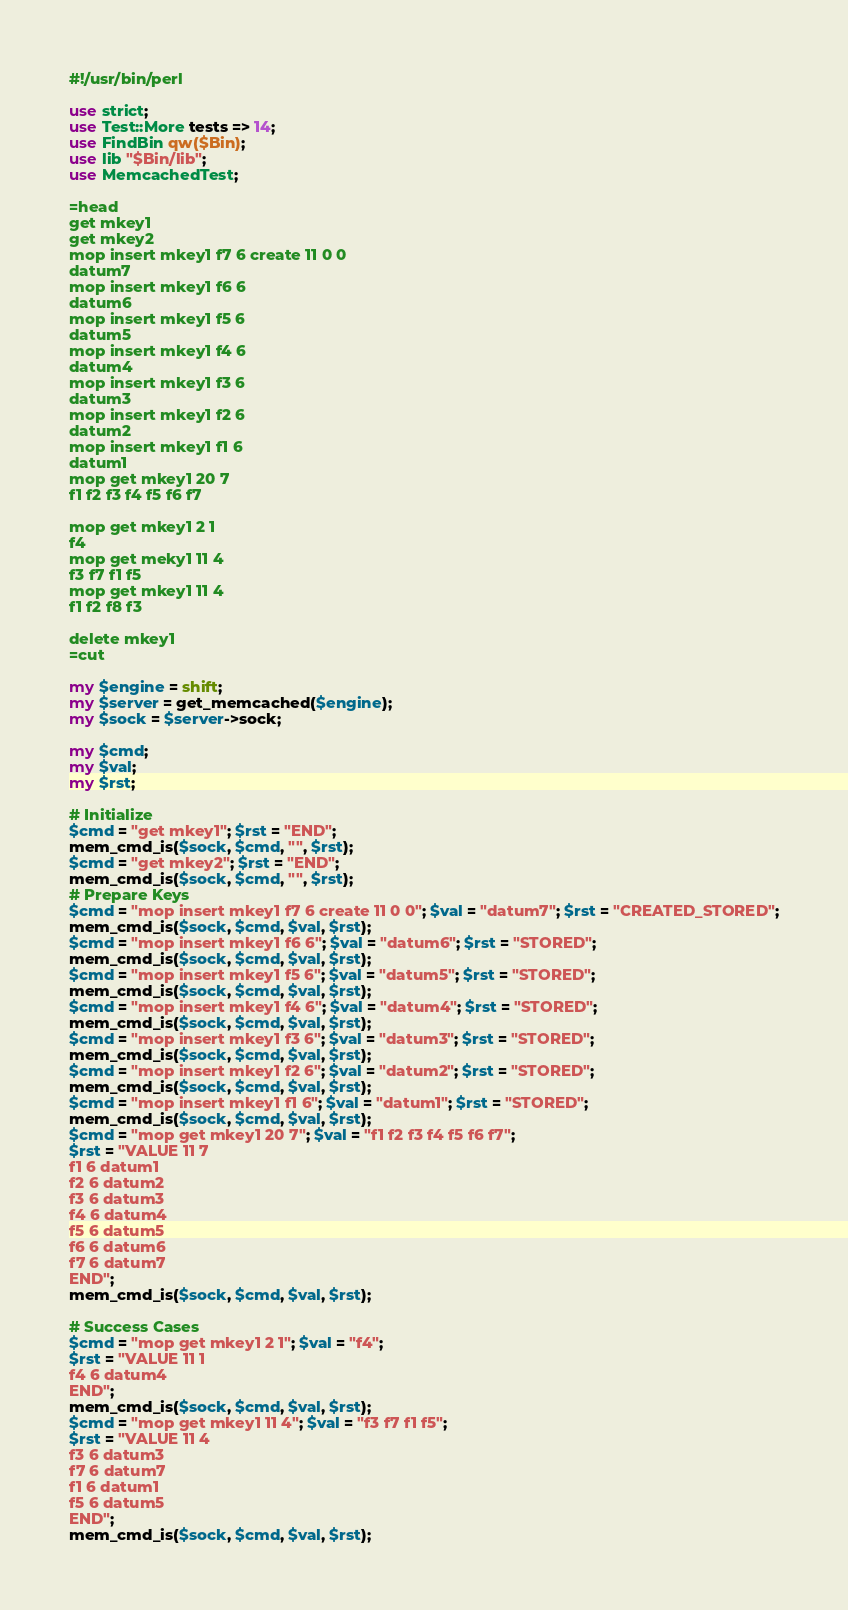<code> <loc_0><loc_0><loc_500><loc_500><_Perl_>#!/usr/bin/perl

use strict;
use Test::More tests => 14;
use FindBin qw($Bin);
use lib "$Bin/lib";
use MemcachedTest;

=head
get mkey1
get mkey2
mop insert mkey1 f7 6 create 11 0 0
datum7
mop insert mkey1 f6 6
datum6
mop insert mkey1 f5 6
datum5
mop insert mkey1 f4 6
datum4
mop insert mkey1 f3 6
datum3
mop insert mkey1 f2 6
datum2
mop insert mkey1 f1 6
datum1
mop get mkey1 20 7
f1 f2 f3 f4 f5 f6 f7

mop get mkey1 2 1
f4
mop get meky1 11 4
f3 f7 f1 f5
mop get mkey1 11 4
f1 f2 f8 f3

delete mkey1
=cut

my $engine = shift;
my $server = get_memcached($engine);
my $sock = $server->sock;

my $cmd;
my $val;
my $rst;

# Initialize
$cmd = "get mkey1"; $rst = "END";
mem_cmd_is($sock, $cmd, "", $rst);
$cmd = "get mkey2"; $rst = "END";
mem_cmd_is($sock, $cmd, "", $rst);
# Prepare Keys
$cmd = "mop insert mkey1 f7 6 create 11 0 0"; $val = "datum7"; $rst = "CREATED_STORED";
mem_cmd_is($sock, $cmd, $val, $rst);
$cmd = "mop insert mkey1 f6 6"; $val = "datum6"; $rst = "STORED";
mem_cmd_is($sock, $cmd, $val, $rst);
$cmd = "mop insert mkey1 f5 6"; $val = "datum5"; $rst = "STORED";
mem_cmd_is($sock, $cmd, $val, $rst);
$cmd = "mop insert mkey1 f4 6"; $val = "datum4"; $rst = "STORED";
mem_cmd_is($sock, $cmd, $val, $rst);
$cmd = "mop insert mkey1 f3 6"; $val = "datum3"; $rst = "STORED";
mem_cmd_is($sock, $cmd, $val, $rst);
$cmd = "mop insert mkey1 f2 6"; $val = "datum2"; $rst = "STORED";
mem_cmd_is($sock, $cmd, $val, $rst);
$cmd = "mop insert mkey1 f1 6"; $val = "datum1"; $rst = "STORED";
mem_cmd_is($sock, $cmd, $val, $rst);
$cmd = "mop get mkey1 20 7"; $val = "f1 f2 f3 f4 f5 f6 f7";
$rst = "VALUE 11 7
f1 6 datum1
f2 6 datum2
f3 6 datum3
f4 6 datum4
f5 6 datum5
f6 6 datum6
f7 6 datum7
END";
mem_cmd_is($sock, $cmd, $val, $rst);

# Success Cases
$cmd = "mop get mkey1 2 1"; $val = "f4";
$rst = "VALUE 11 1
f4 6 datum4
END";
mem_cmd_is($sock, $cmd, $val, $rst);
$cmd = "mop get mkey1 11 4"; $val = "f3 f7 f1 f5";
$rst = "VALUE 11 4
f3 6 datum3
f7 6 datum7
f1 6 datum1
f5 6 datum5
END";
mem_cmd_is($sock, $cmd, $val, $rst);</code> 